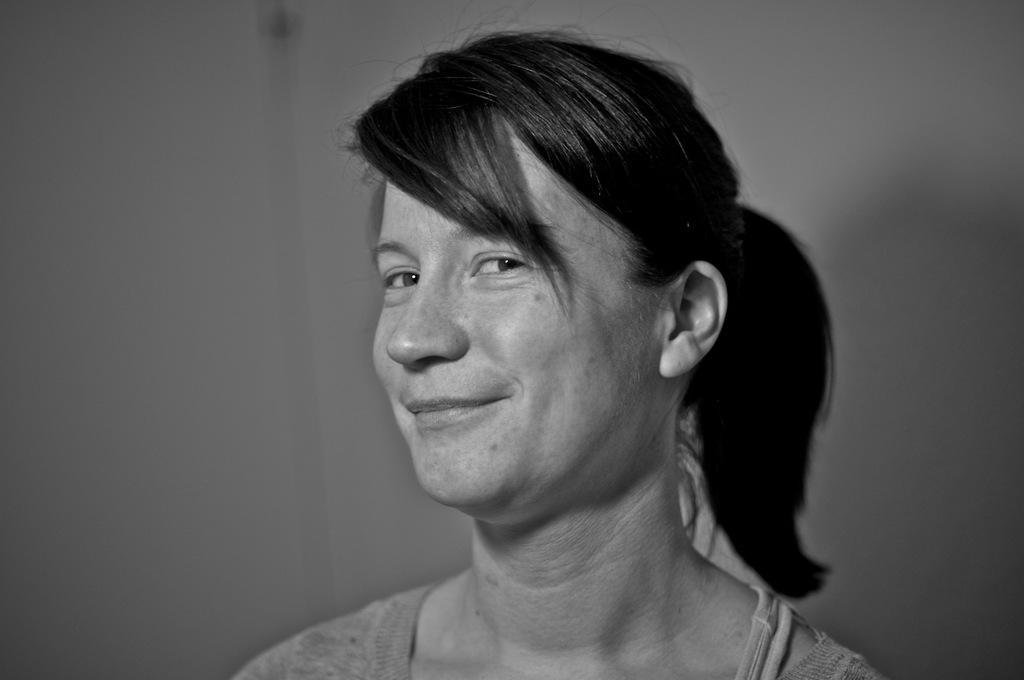Please provide a concise description of this image. In this image we can see a lady, behind her we can see the wall, and the picture is taken in black and white mode. 